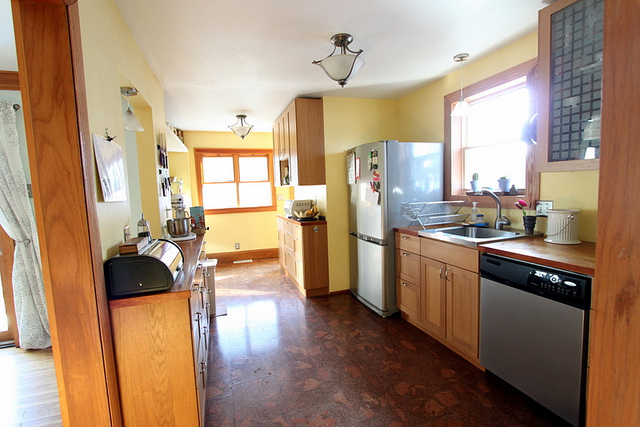How does the light fixture design contribute to the room's overall aesthetic? The light fixtures with their simple, understated design and frosted glass shades complement the minimalist and functional aesthetic of this kitchen, enhancing its bright and airy feel. 